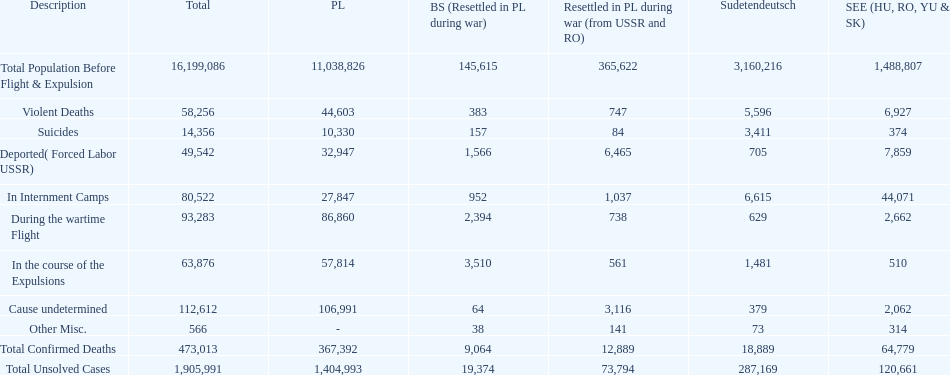Which region had the least total of unsolved cases? Baltic States(Resettled in Poland during war). 